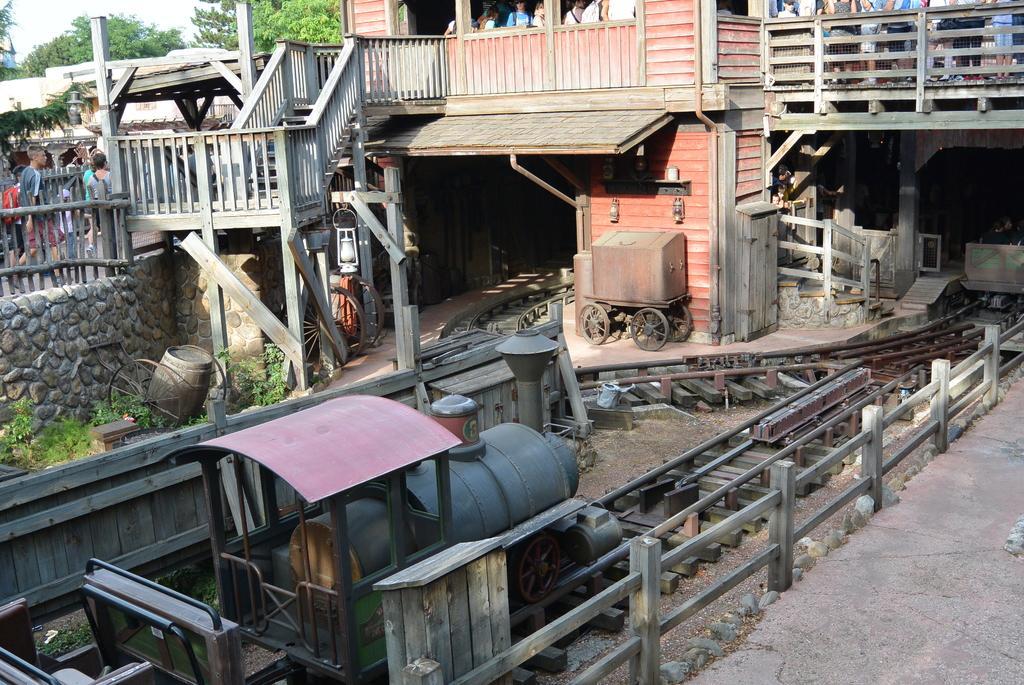Could you give a brief overview of what you see in this image? On the left side, there is a train on a railway track. On both sides of this railway track, there is a fence. In the background, there is a wall, there is a bridge having a fence on both sides, on this bridge there are persons, there are trees and there are clouds in the sky. 